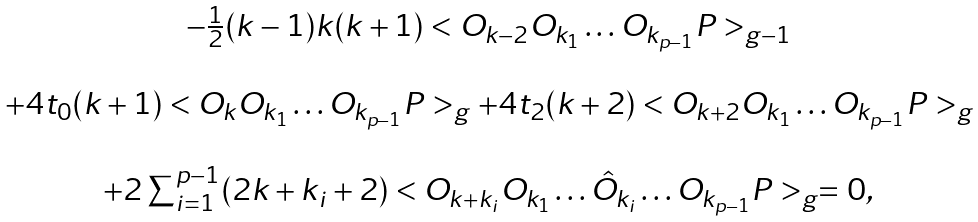<formula> <loc_0><loc_0><loc_500><loc_500>\begin{array} { c } - \frac { 1 } { 2 } ( k - 1 ) k ( k + 1 ) < O _ { k - 2 } O _ { k _ { 1 } } \dots O _ { k _ { p - 1 } } P > _ { g - 1 } \\ \\ + 4 t _ { 0 } ( k + 1 ) < O _ { k } O _ { k _ { 1 } } \dots O _ { k _ { p - 1 } } P > _ { g } + 4 t _ { 2 } ( k + 2 ) < O _ { k + 2 } O _ { k _ { 1 } } \dots O _ { k _ { p - 1 } } P > _ { g } \\ \\ + 2 \sum _ { i = 1 } ^ { p - 1 } ( 2 k + k _ { i } + 2 ) < O _ { k + k _ { i } } O _ { k _ { 1 } } \dots \hat { O } _ { k _ { i } } \dots O _ { k _ { p - 1 } } P > _ { g } = 0 , \end{array}</formula> 